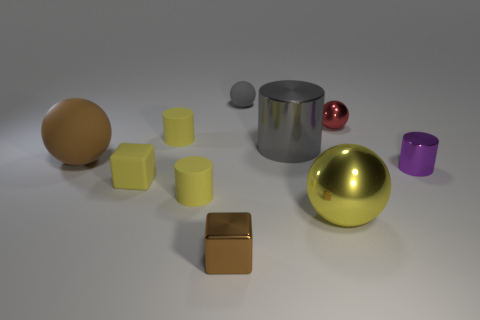What size is the ball that is the same color as the shiny cube?
Offer a terse response. Large. There is a brown object behind the small brown block that is to the left of the big yellow metal thing; what is its shape?
Make the answer very short. Sphere. There is a yellow metallic thing; is it the same shape as the tiny shiny thing that is behind the large brown object?
Your answer should be very brief. Yes. The metal block that is the same size as the matte cube is what color?
Ensure brevity in your answer.  Brown. Is the number of yellow blocks on the right side of the purple thing less than the number of shiny cylinders behind the small brown shiny cube?
Make the answer very short. Yes. What is the shape of the small thing that is in front of the yellow matte cylinder that is in front of the brown object that is on the left side of the small rubber cube?
Make the answer very short. Cube. There is a small cube left of the brown shiny block; is it the same color as the ball in front of the brown rubber object?
Provide a succinct answer. Yes. What shape is the big matte object that is the same color as the small metallic cube?
Your response must be concise. Sphere. How many matte objects are big brown spheres or red objects?
Your response must be concise. 1. What color is the tiny cube that is in front of the metal ball in front of the gray object that is right of the tiny gray sphere?
Offer a very short reply. Brown. 